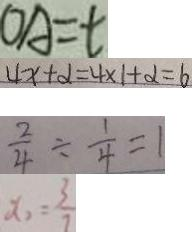<formula> <loc_0><loc_0><loc_500><loc_500>O A = t 
 4 x + \alpha = 4 \times 1 + \alpha = 6 
 \frac { 2 } { 4 } \div \frac { 1 } { 4 } = 1 
 x _ { 2 } = \frac { 3 } { 7 }</formula> 